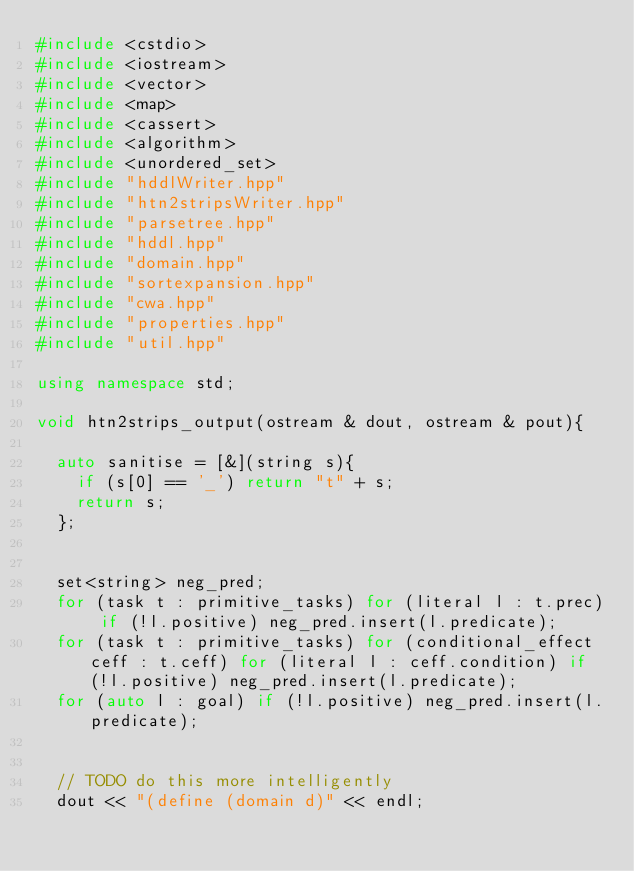<code> <loc_0><loc_0><loc_500><loc_500><_C++_>#include <cstdio>
#include <iostream>
#include <vector>
#include <map>
#include <cassert>
#include <algorithm>
#include <unordered_set>
#include "hddlWriter.hpp"
#include "htn2stripsWriter.hpp"
#include "parsetree.hpp"
#include "hddl.hpp"
#include "domain.hpp"
#include "sortexpansion.hpp"
#include "cwa.hpp"
#include "properties.hpp"
#include "util.hpp"

using namespace std;

void htn2strips_output(ostream & dout, ostream & pout){

	auto sanitise = [&](string s){
		if (s[0] == '_') return "t" + s;
		return s;
	};


	set<string> neg_pred;
	for (task t : primitive_tasks) for (literal l : t.prec) if (!l.positive) neg_pred.insert(l.predicate);
	for (task t : primitive_tasks) for (conditional_effect ceff : t.ceff) for (literal l : ceff.condition) if (!l.positive) neg_pred.insert(l.predicate);
	for (auto l : goal) if (!l.positive) neg_pred.insert(l.predicate);


	// TODO do this more intelligently
	dout << "(define (domain d)" << endl;</code> 